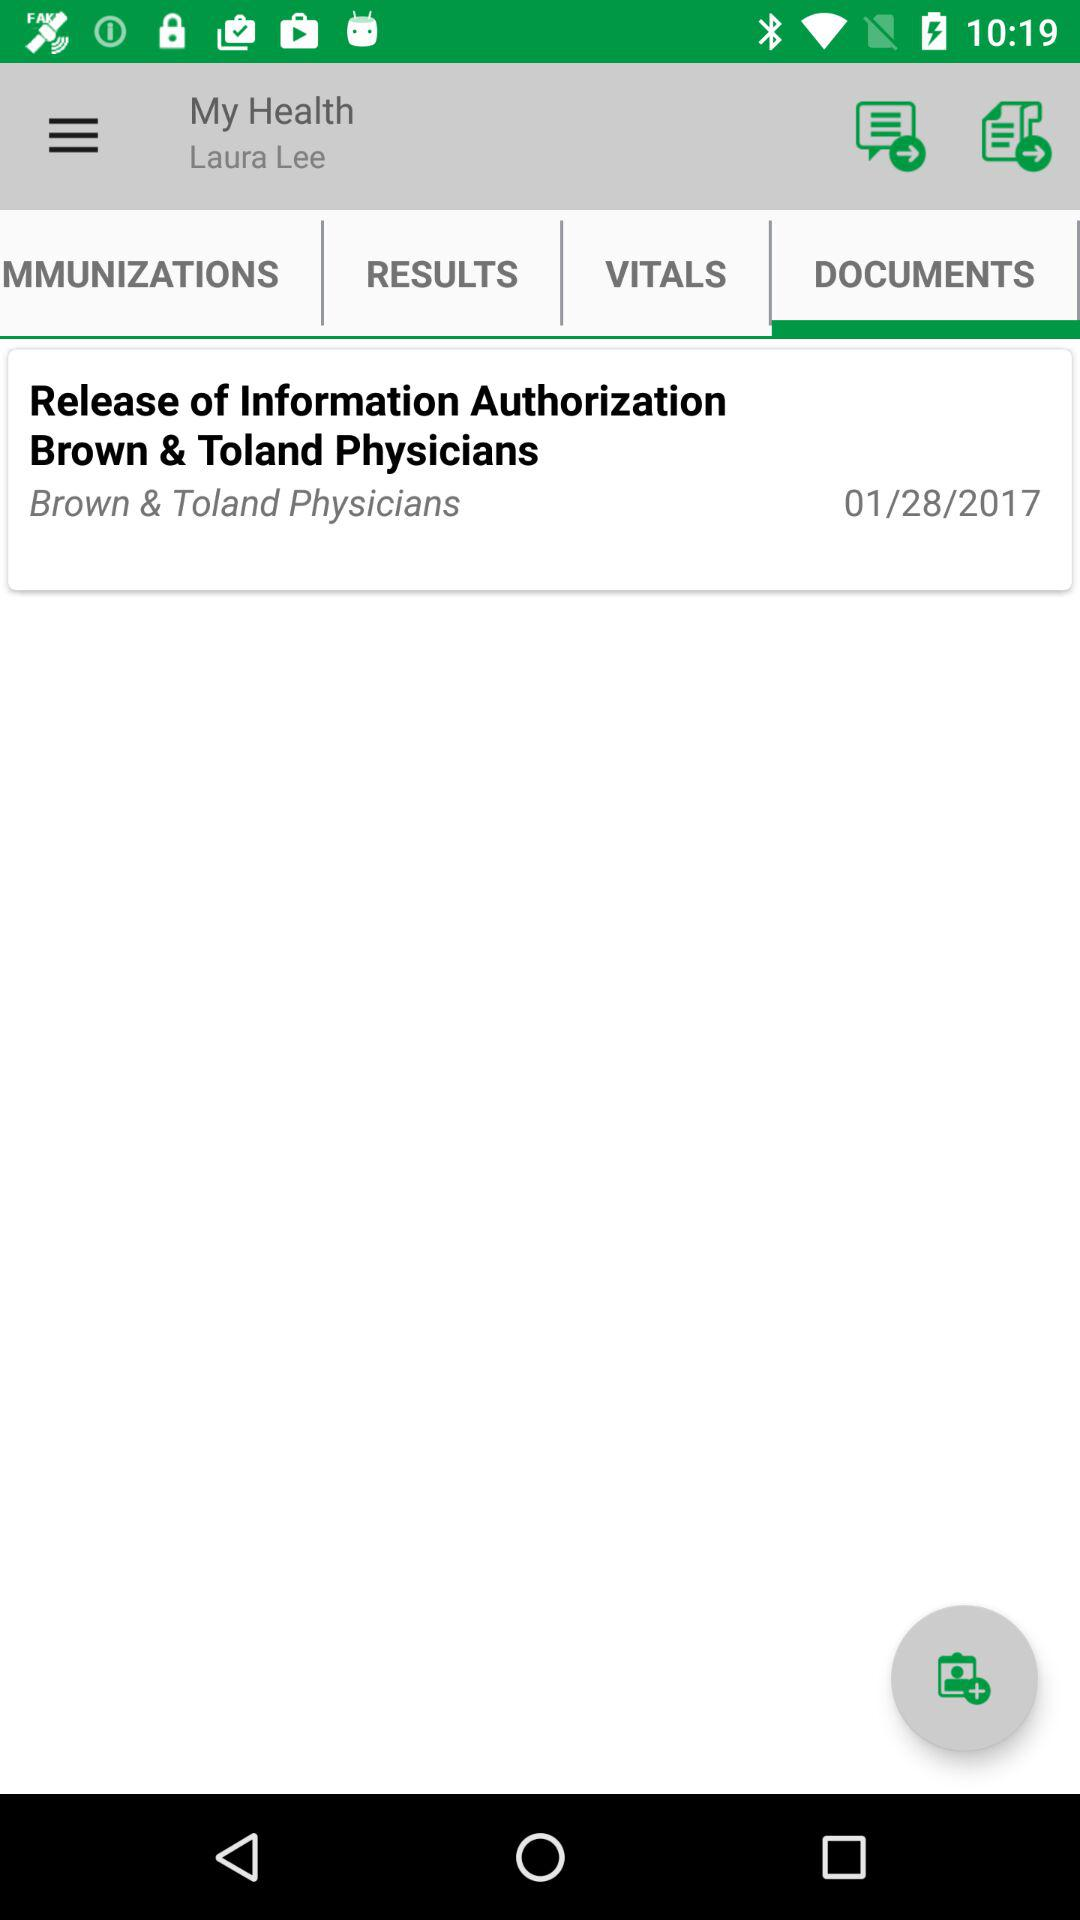What's the username? The username is Laura Lee. 